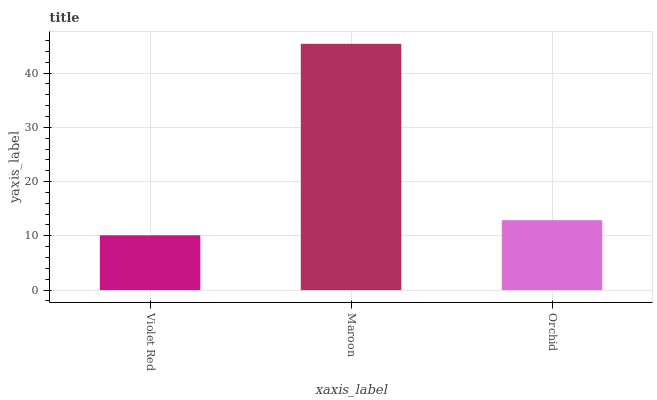Is Violet Red the minimum?
Answer yes or no. Yes. Is Maroon the maximum?
Answer yes or no. Yes. Is Orchid the minimum?
Answer yes or no. No. Is Orchid the maximum?
Answer yes or no. No. Is Maroon greater than Orchid?
Answer yes or no. Yes. Is Orchid less than Maroon?
Answer yes or no. Yes. Is Orchid greater than Maroon?
Answer yes or no. No. Is Maroon less than Orchid?
Answer yes or no. No. Is Orchid the high median?
Answer yes or no. Yes. Is Orchid the low median?
Answer yes or no. Yes. Is Violet Red the high median?
Answer yes or no. No. Is Maroon the low median?
Answer yes or no. No. 